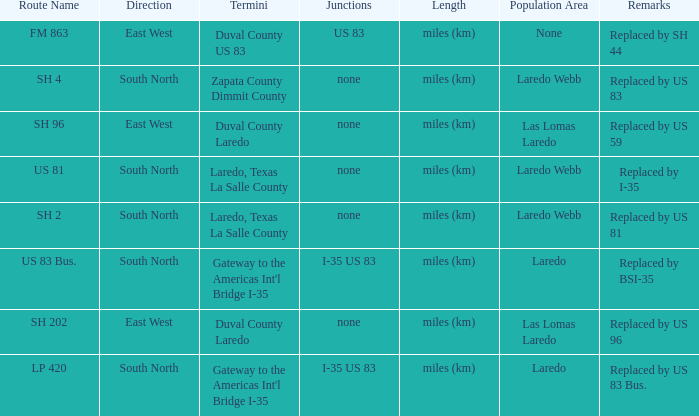Which routes have  "replaced by US 81" listed in their remarks section? SH 2. 